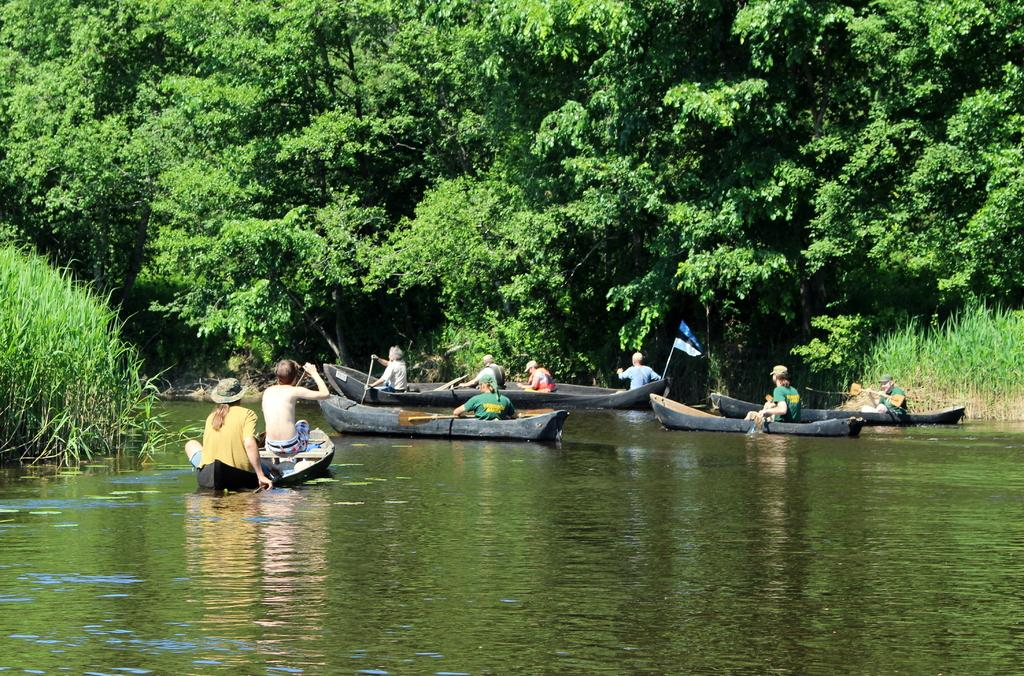What are the people in the image doing? There are persons sitting in the boat in the image. Where is the boat located? The boat is on the water. What can be seen in the background of the image? There are trees visible in the background. What is the color of the trees in the image? The trees are green in color. How many minutes does it take for the boat to burn in the image? There is no indication of the boat burning in the image, so it is not possible to answer that question. 